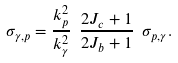Convert formula to latex. <formula><loc_0><loc_0><loc_500><loc_500>\sigma _ { \gamma , p } = \frac { k _ { p } ^ { 2 } } { k _ { \gamma } ^ { 2 } } \ \frac { 2 J _ { c } + 1 } { 2 J _ { b } + 1 } \ \sigma _ { p , \gamma } .</formula> 